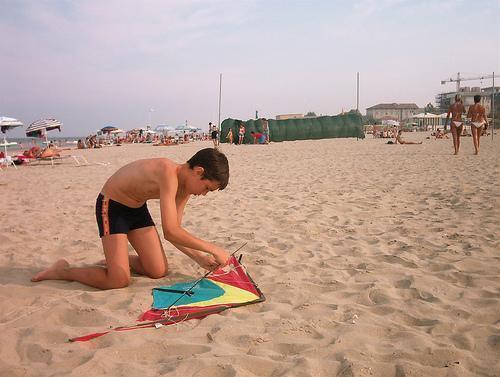Where does he hope his toy will go?
Answer the question by selecting the correct answer among the 4 following choices and explain your choice with a short sentence. The answer should be formatted with the following format: `Answer: choice
Rationale: rationale.`
Options: Sky, trees, water, sand. Answer: sky.
Rationale: The boy is playing with a kite on the beach. 